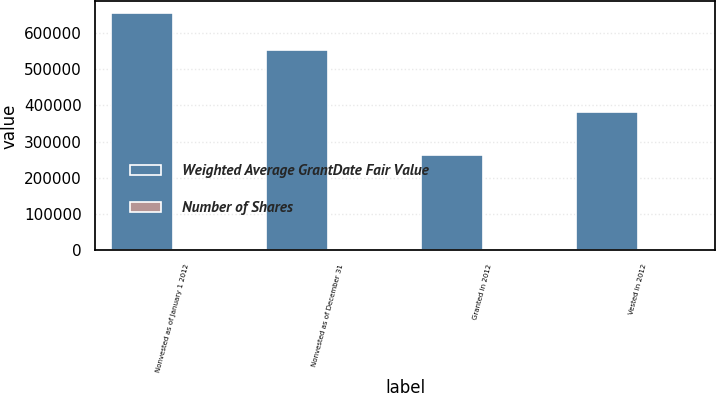Convert chart to OTSL. <chart><loc_0><loc_0><loc_500><loc_500><stacked_bar_chart><ecel><fcel>Nonvested as of January 1 2012<fcel>Nonvested as of December 31<fcel>Granted in 2012<fcel>Vested in 2012<nl><fcel>Weighted Average GrantDate Fair Value<fcel>654696<fcel>551678<fcel>263771<fcel>380970<nl><fcel>Number of Shares<fcel>45.26<fcel>47.21<fcel>44.82<fcel>42.75<nl></chart> 